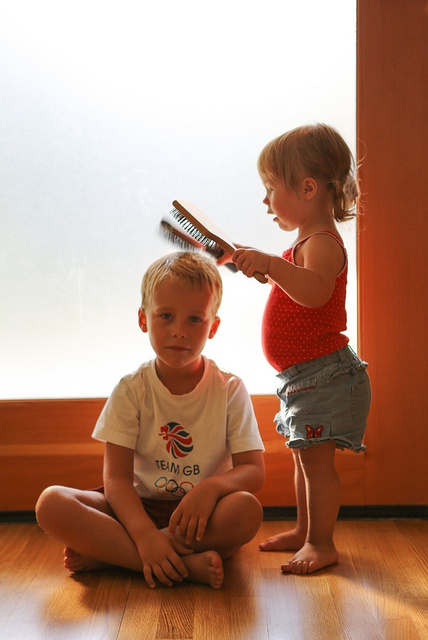Describe the objects in this image and their specific colors. I can see people in white, maroon, brown, and gray tones and people in white, maroon, and brown tones in this image. 